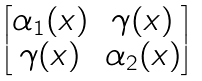<formula> <loc_0><loc_0><loc_500><loc_500>\begin{bmatrix} \alpha _ { 1 } ( x ) & \gamma ( x ) \\ \gamma ( x ) & \alpha _ { 2 } ( x ) \end{bmatrix}</formula> 